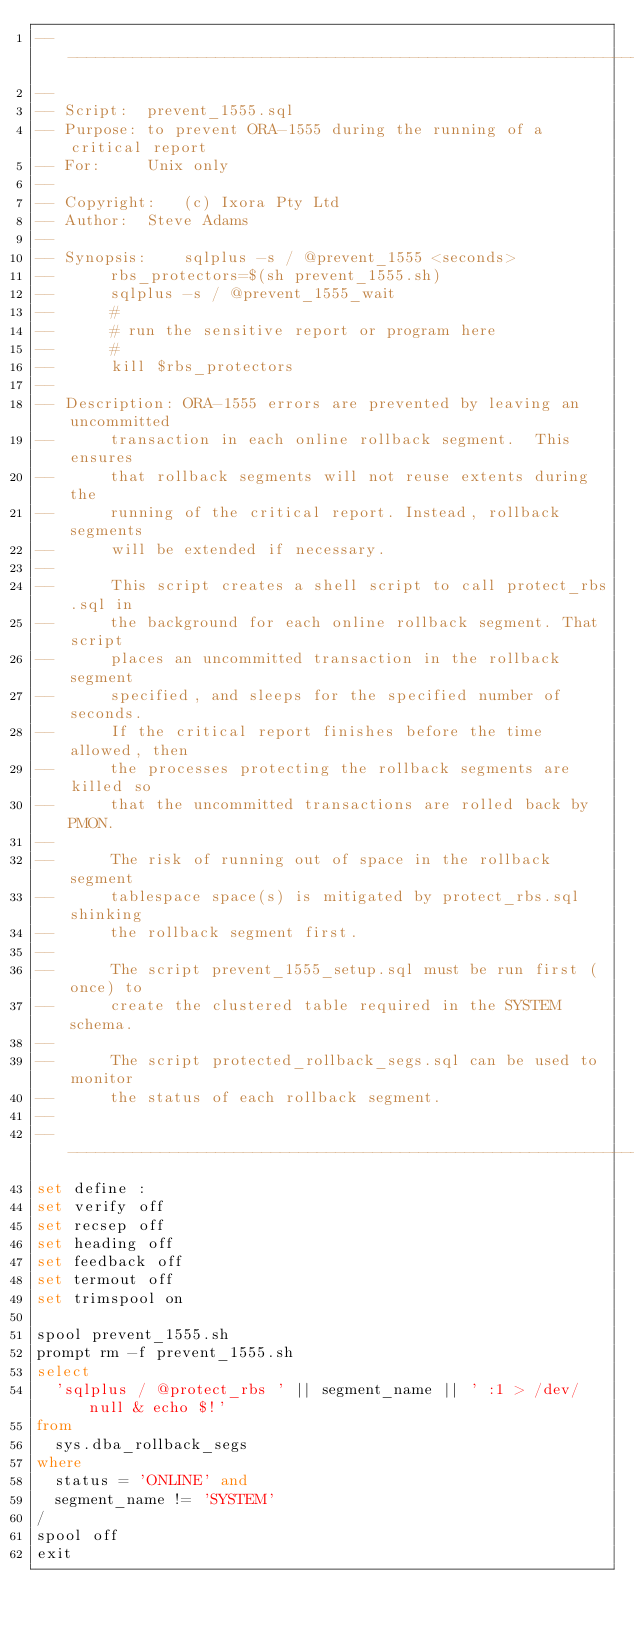<code> <loc_0><loc_0><loc_500><loc_500><_SQL_>-------------------------------------------------------------------------------
--
-- Script:	prevent_1555.sql
-- Purpose:	to prevent ORA-1555 during the running of a critical report
-- For:		Unix only
--
-- Copyright:	(c) Ixora Pty Ltd
-- Author:	Steve Adams
--
-- Synopsis:	sqlplus -s / @prevent_1555 <seconds>
--		rbs_protectors=$(sh prevent_1555.sh)
--		sqlplus -s / @prevent_1555_wait
--		#
--		# run the sensitive report or program here
--		#
--		kill $rbs_protectors
--
-- Description:	ORA-1555 errors are prevented by leaving an uncommitted
--		transaction in each online rollback segment.  This ensures
--		that rollback segments will not reuse extents during the
--		running of the critical report. Instead, rollback segments
--		will be extended if necessary.
--
--		This script creates a shell script to call protect_rbs.sql in
--		the background for each online rollback segment. That script
--		places an uncommitted transaction in the rollback segment
--		specified, and sleeps for the specified number of seconds.
--		If the critical report finishes before the time allowed, then
--		the processes protecting the rollback segments are killed so
--		that the uncommitted transactions are rolled back by PMON.
--
--		The risk of running out of space in the rollback segment
--		tablespace space(s) is mitigated by protect_rbs.sql shinking
--		the rollback segment first.
--
--		The script prevent_1555_setup.sql must be run first (once) to
--		create the clustered table required in the SYSTEM schema.
--
--		The script protected_rollback_segs.sql can be used to monitor
--		the status of each rollback segment.
--
-------------------------------------------------------------------------------
set define :
set verify off
set recsep off
set heading off
set feedback off
set termout off
set trimspool on

spool prevent_1555.sh
prompt rm -f prevent_1555.sh
select
  'sqlplus / @protect_rbs ' || segment_name || ' :1 > /dev/null & echo $!'
from
  sys.dba_rollback_segs
where
  status = 'ONLINE' and
  segment_name != 'SYSTEM'
/
spool off
exit
</code> 